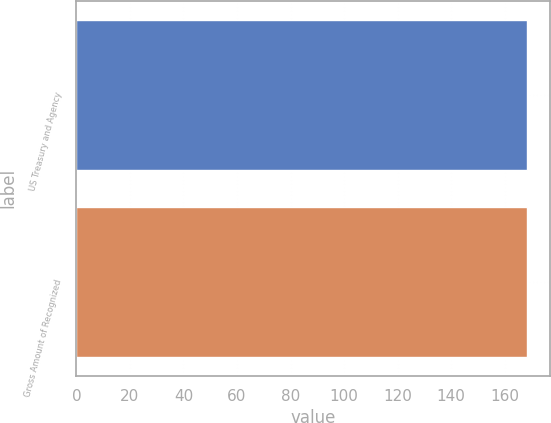Convert chart. <chart><loc_0><loc_0><loc_500><loc_500><bar_chart><fcel>US Treasury and Agency<fcel>Gross Amount of Recognized<nl><fcel>168.3<fcel>168.4<nl></chart> 